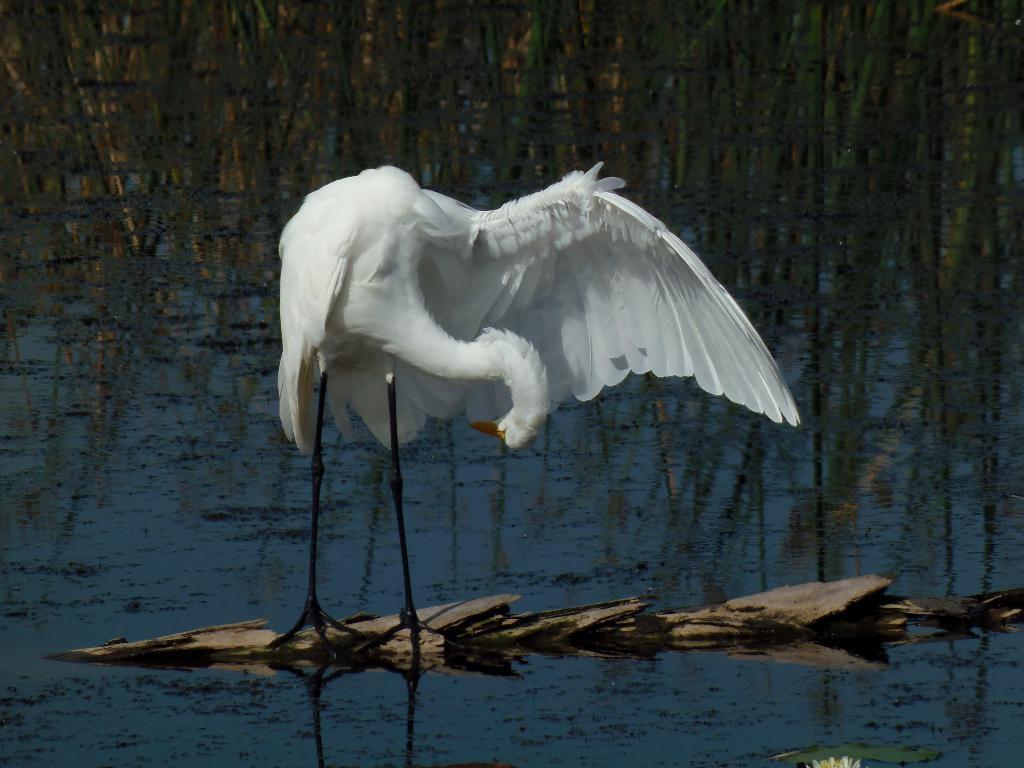What is the main subject of the image? There is a crane in the image. What is the crane standing on? The crane is standing on a wooden platform. What can be seen in the background of the image? There are plants in the background of the image. What is visible in the image besides the crane and wooden platform? There is water visible in the image. What type of cast can be seen on the crane's leg in the image? There is no cast visible on the crane's leg in the image, as cranes do not have legs like animals. 